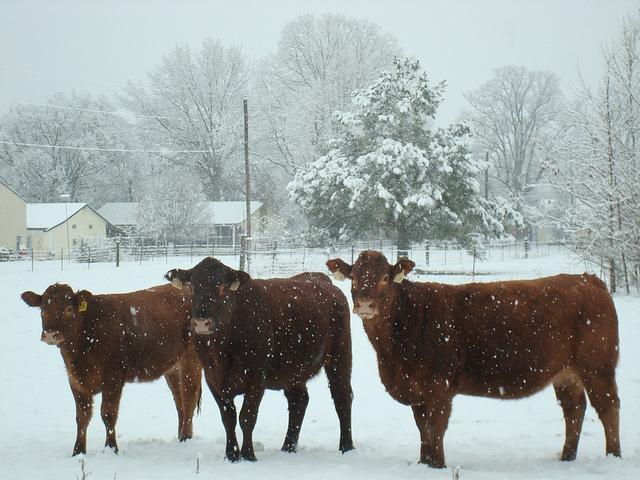How many animals are there?
Give a very brief answer. 3. How many cows can you see?
Give a very brief answer. 3. 